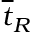<formula> <loc_0><loc_0><loc_500><loc_500>\overline { t } _ { R }</formula> 